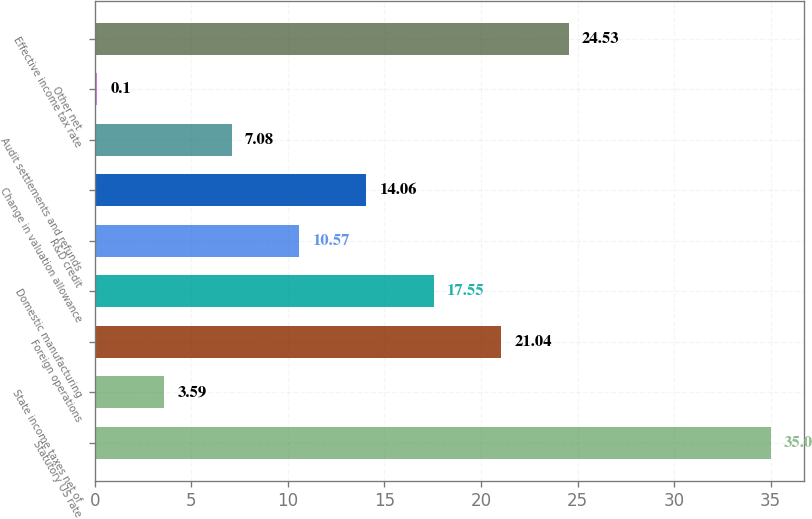Convert chart to OTSL. <chart><loc_0><loc_0><loc_500><loc_500><bar_chart><fcel>Statutory US rate<fcel>State income taxes net of<fcel>Foreign operations<fcel>Domestic manufacturing<fcel>R&D credit<fcel>Change in valuation allowance<fcel>Audit settlements and refunds<fcel>Other net<fcel>Effective income tax rate<nl><fcel>35<fcel>3.59<fcel>21.04<fcel>17.55<fcel>10.57<fcel>14.06<fcel>7.08<fcel>0.1<fcel>24.53<nl></chart> 